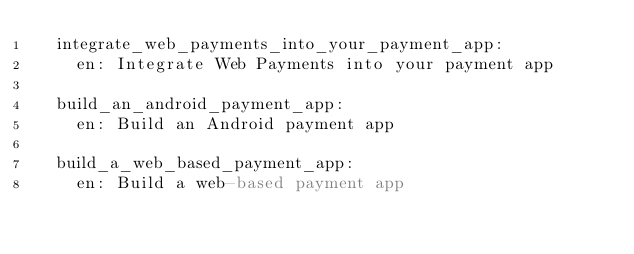Convert code to text. <code><loc_0><loc_0><loc_500><loc_500><_YAML_>  integrate_web_payments_into_your_payment_app:
    en: Integrate Web Payments into your payment app

  build_an_android_payment_app:
    en: Build an Android payment app

  build_a_web_based_payment_app:
    en: Build a web-based payment app
</code> 